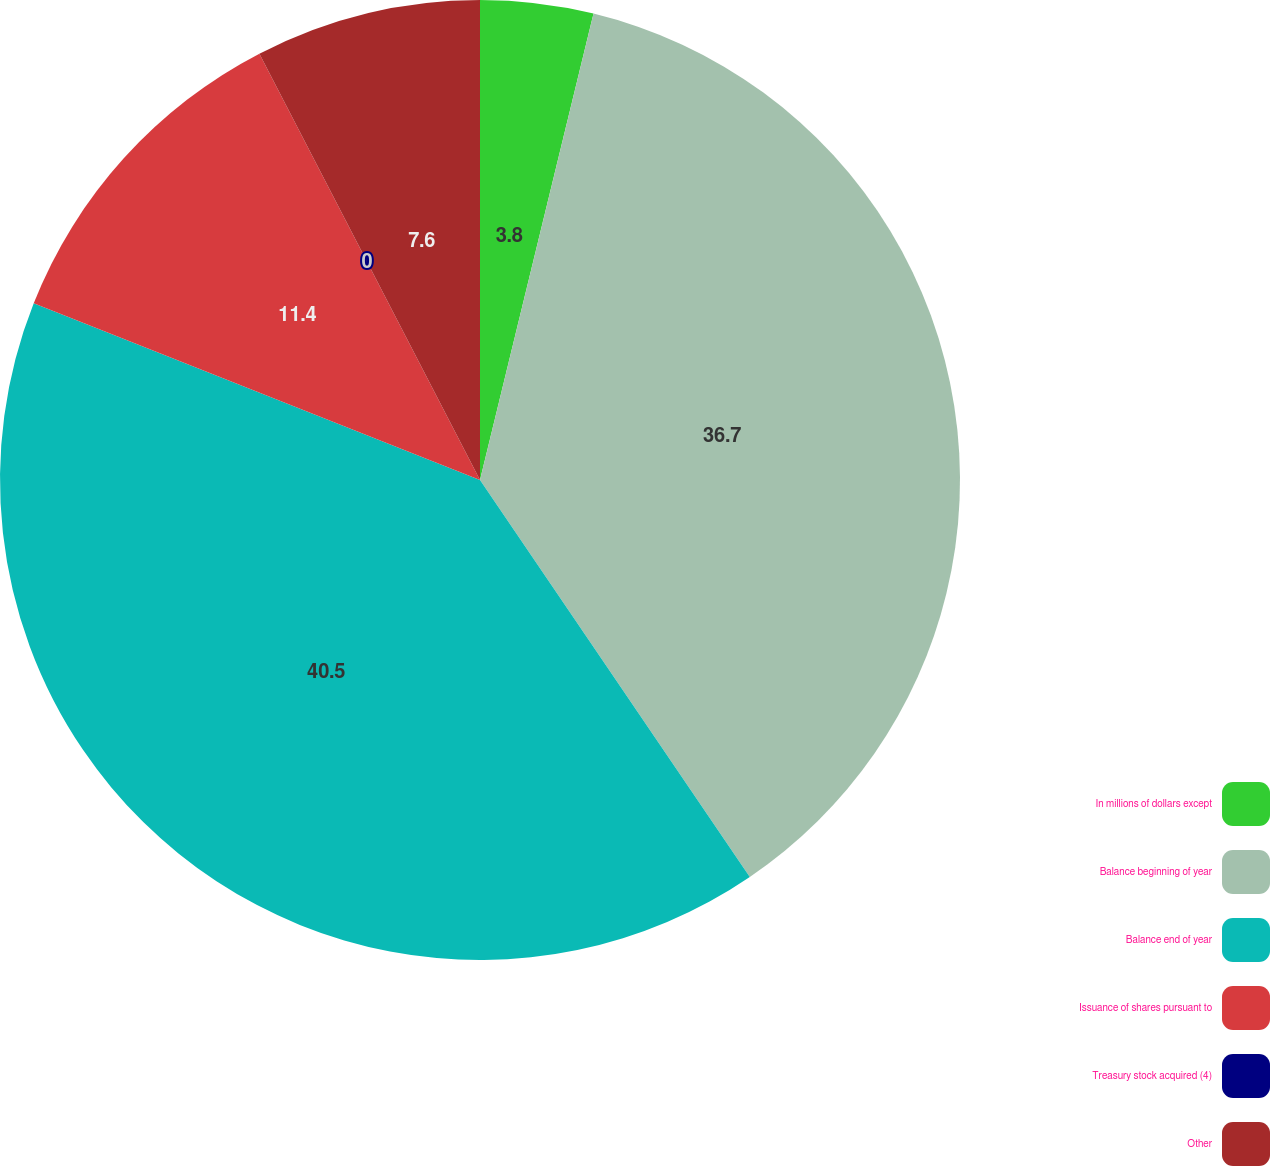Convert chart. <chart><loc_0><loc_0><loc_500><loc_500><pie_chart><fcel>In millions of dollars except<fcel>Balance beginning of year<fcel>Balance end of year<fcel>Issuance of shares pursuant to<fcel>Treasury stock acquired (4)<fcel>Other<nl><fcel>3.8%<fcel>36.7%<fcel>40.5%<fcel>11.4%<fcel>0.0%<fcel>7.6%<nl></chart> 